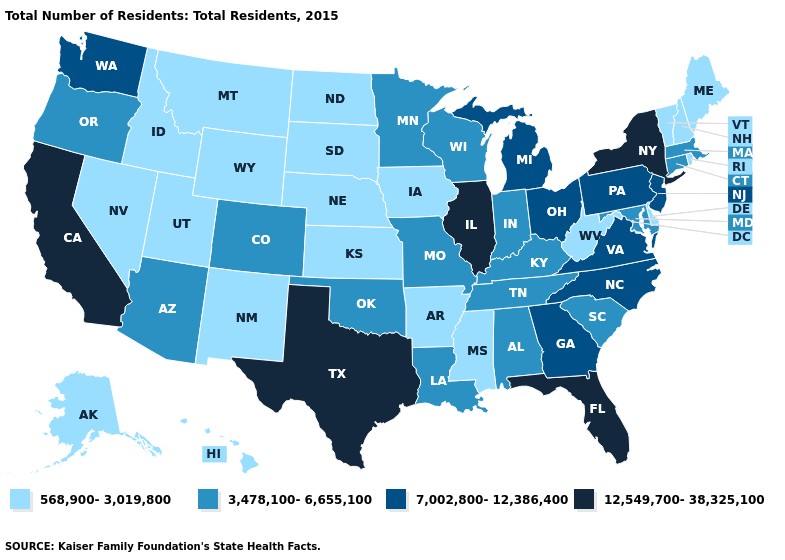Name the states that have a value in the range 568,900-3,019,800?
Be succinct. Alaska, Arkansas, Delaware, Hawaii, Idaho, Iowa, Kansas, Maine, Mississippi, Montana, Nebraska, Nevada, New Hampshire, New Mexico, North Dakota, Rhode Island, South Dakota, Utah, Vermont, West Virginia, Wyoming. What is the value of South Carolina?
Short answer required. 3,478,100-6,655,100. Which states hav the highest value in the West?
Keep it brief. California. What is the value of North Carolina?
Concise answer only. 7,002,800-12,386,400. What is the value of Texas?
Quick response, please. 12,549,700-38,325,100. Name the states that have a value in the range 7,002,800-12,386,400?
Write a very short answer. Georgia, Michigan, New Jersey, North Carolina, Ohio, Pennsylvania, Virginia, Washington. How many symbols are there in the legend?
Write a very short answer. 4. What is the value of Missouri?
Concise answer only. 3,478,100-6,655,100. Name the states that have a value in the range 7,002,800-12,386,400?
Concise answer only. Georgia, Michigan, New Jersey, North Carolina, Ohio, Pennsylvania, Virginia, Washington. What is the lowest value in the USA?
Answer briefly. 568,900-3,019,800. What is the value of Maryland?
Quick response, please. 3,478,100-6,655,100. Which states have the lowest value in the USA?
Write a very short answer. Alaska, Arkansas, Delaware, Hawaii, Idaho, Iowa, Kansas, Maine, Mississippi, Montana, Nebraska, Nevada, New Hampshire, New Mexico, North Dakota, Rhode Island, South Dakota, Utah, Vermont, West Virginia, Wyoming. Does Colorado have the highest value in the USA?
Concise answer only. No. 